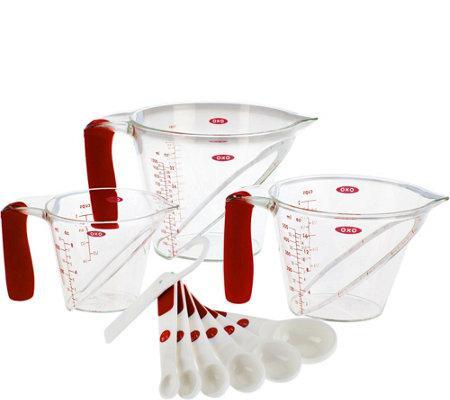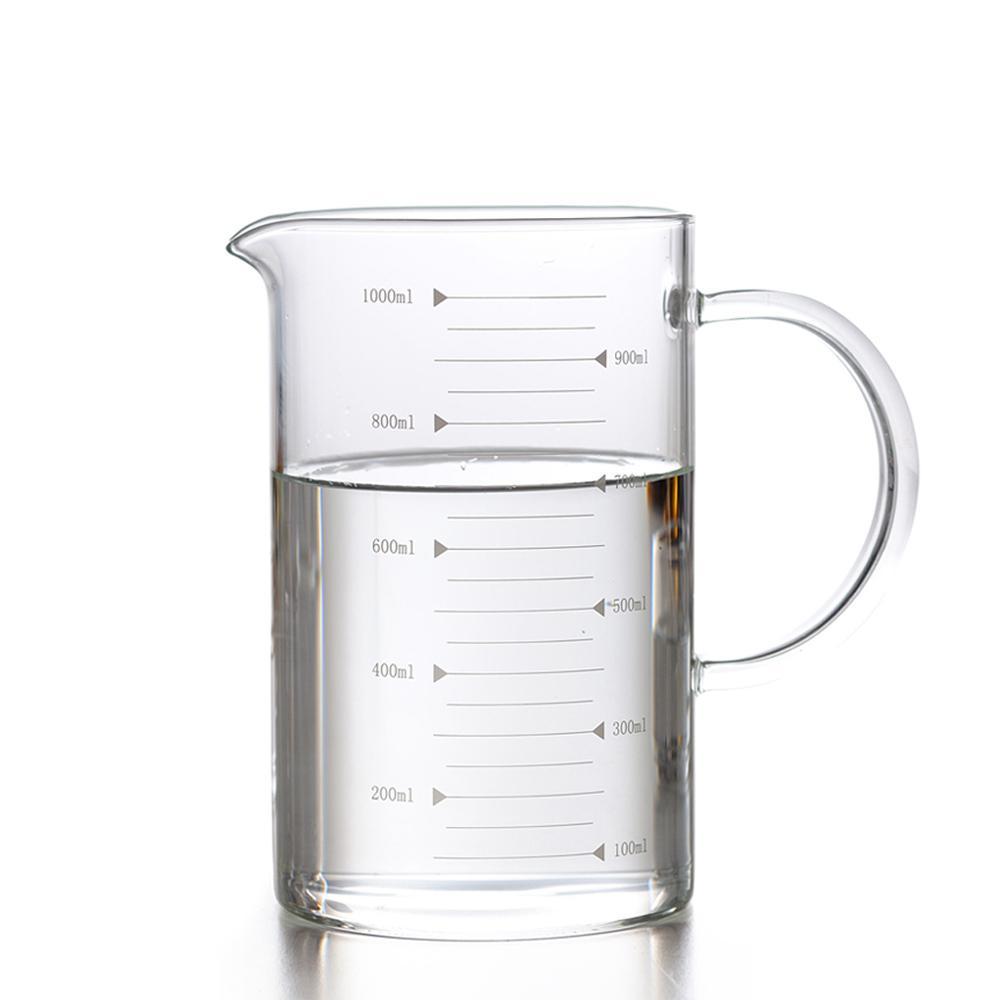The first image is the image on the left, the second image is the image on the right. Evaluate the accuracy of this statement regarding the images: "A set of three clear measuring cups have red markings.". Is it true? Answer yes or no. Yes. The first image is the image on the left, the second image is the image on the right. For the images displayed, is the sentence "The left image shows a set of measuring spoons" factually correct? Answer yes or no. Yes. 